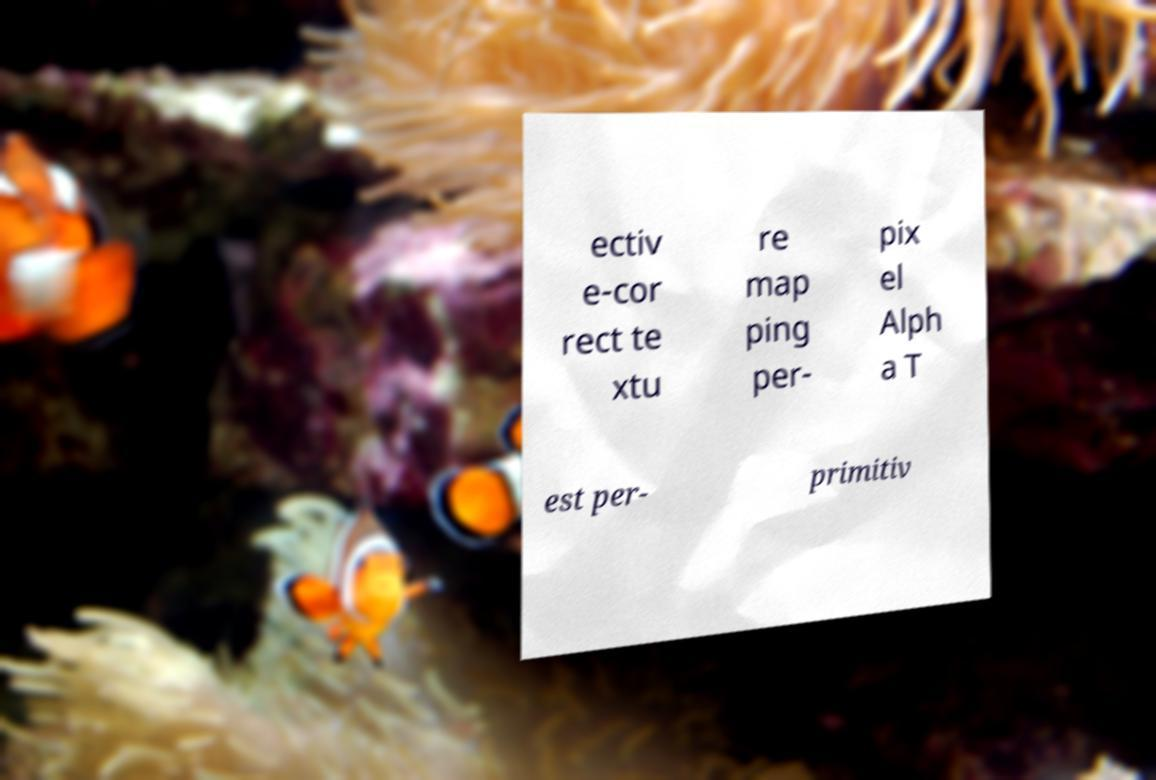Can you accurately transcribe the text from the provided image for me? ectiv e-cor rect te xtu re map ping per- pix el Alph a T est per- primitiv 